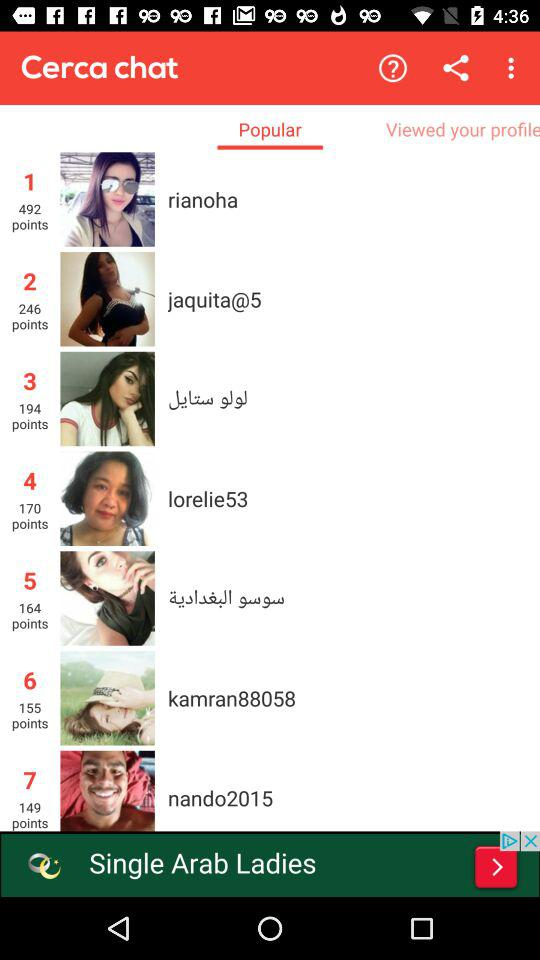How many points does "rianoha" have? "rianoha" has 492 points. 